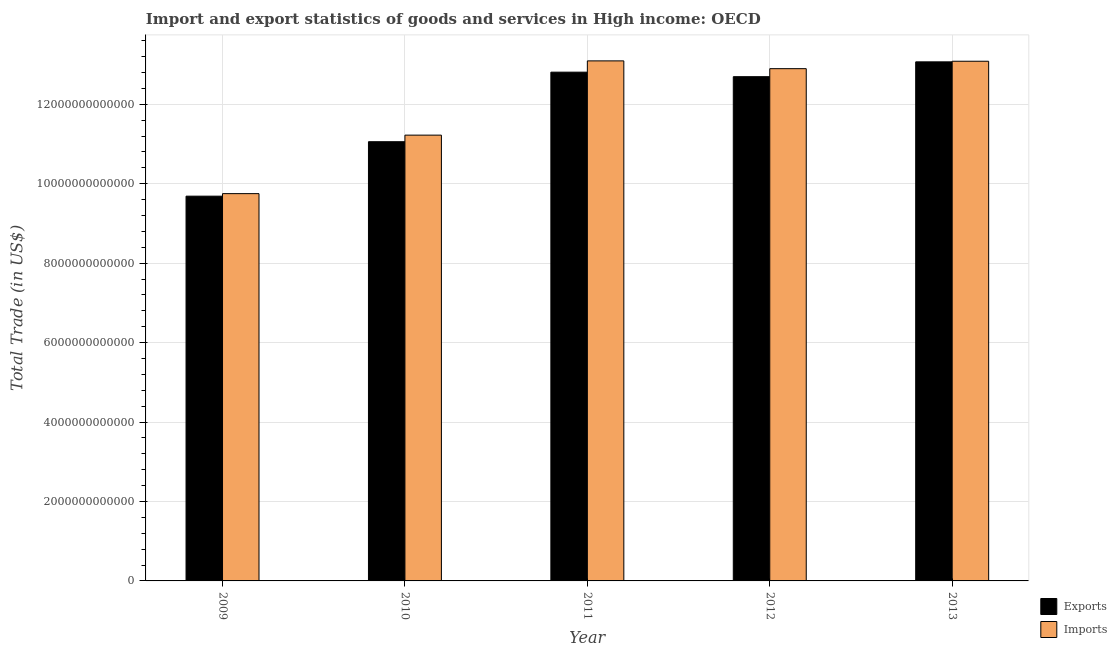How many different coloured bars are there?
Your answer should be very brief. 2. How many groups of bars are there?
Keep it short and to the point. 5. How many bars are there on the 1st tick from the left?
Your answer should be compact. 2. How many bars are there on the 5th tick from the right?
Provide a short and direct response. 2. What is the export of goods and services in 2009?
Give a very brief answer. 9.69e+12. Across all years, what is the maximum export of goods and services?
Offer a terse response. 1.31e+13. Across all years, what is the minimum export of goods and services?
Keep it short and to the point. 9.69e+12. In which year was the export of goods and services maximum?
Your response must be concise. 2013. What is the total export of goods and services in the graph?
Make the answer very short. 5.93e+13. What is the difference between the imports of goods and services in 2010 and that in 2011?
Ensure brevity in your answer.  -1.87e+12. What is the difference between the imports of goods and services in 2011 and the export of goods and services in 2012?
Provide a short and direct response. 1.96e+11. What is the average export of goods and services per year?
Offer a very short reply. 1.19e+13. In the year 2012, what is the difference between the imports of goods and services and export of goods and services?
Provide a succinct answer. 0. In how many years, is the imports of goods and services greater than 12000000000000 US$?
Your answer should be very brief. 3. What is the ratio of the export of goods and services in 2011 to that in 2013?
Your response must be concise. 0.98. Is the difference between the export of goods and services in 2009 and 2010 greater than the difference between the imports of goods and services in 2009 and 2010?
Offer a terse response. No. What is the difference between the highest and the second highest imports of goods and services?
Offer a terse response. 9.21e+09. What is the difference between the highest and the lowest imports of goods and services?
Make the answer very short. 3.34e+12. Is the sum of the export of goods and services in 2009 and 2012 greater than the maximum imports of goods and services across all years?
Your answer should be compact. Yes. What does the 1st bar from the left in 2013 represents?
Your answer should be very brief. Exports. What does the 2nd bar from the right in 2012 represents?
Offer a terse response. Exports. How many bars are there?
Make the answer very short. 10. Are all the bars in the graph horizontal?
Keep it short and to the point. No. How many years are there in the graph?
Keep it short and to the point. 5. What is the difference between two consecutive major ticks on the Y-axis?
Your answer should be compact. 2.00e+12. Does the graph contain any zero values?
Make the answer very short. No. Does the graph contain grids?
Your answer should be very brief. Yes. Where does the legend appear in the graph?
Make the answer very short. Bottom right. How many legend labels are there?
Provide a short and direct response. 2. What is the title of the graph?
Your answer should be compact. Import and export statistics of goods and services in High income: OECD. Does "Male population" appear as one of the legend labels in the graph?
Offer a very short reply. No. What is the label or title of the Y-axis?
Make the answer very short. Total Trade (in US$). What is the Total Trade (in US$) of Exports in 2009?
Keep it short and to the point. 9.69e+12. What is the Total Trade (in US$) in Imports in 2009?
Provide a short and direct response. 9.75e+12. What is the Total Trade (in US$) in Exports in 2010?
Offer a very short reply. 1.11e+13. What is the Total Trade (in US$) of Imports in 2010?
Ensure brevity in your answer.  1.12e+13. What is the Total Trade (in US$) in Exports in 2011?
Provide a succinct answer. 1.28e+13. What is the Total Trade (in US$) of Imports in 2011?
Provide a succinct answer. 1.31e+13. What is the Total Trade (in US$) in Exports in 2012?
Make the answer very short. 1.27e+13. What is the Total Trade (in US$) of Imports in 2012?
Provide a succinct answer. 1.29e+13. What is the Total Trade (in US$) of Exports in 2013?
Offer a very short reply. 1.31e+13. What is the Total Trade (in US$) of Imports in 2013?
Provide a succinct answer. 1.31e+13. Across all years, what is the maximum Total Trade (in US$) of Exports?
Offer a terse response. 1.31e+13. Across all years, what is the maximum Total Trade (in US$) in Imports?
Keep it short and to the point. 1.31e+13. Across all years, what is the minimum Total Trade (in US$) in Exports?
Provide a short and direct response. 9.69e+12. Across all years, what is the minimum Total Trade (in US$) in Imports?
Offer a terse response. 9.75e+12. What is the total Total Trade (in US$) in Exports in the graph?
Make the answer very short. 5.93e+13. What is the total Total Trade (in US$) of Imports in the graph?
Provide a short and direct response. 6.00e+13. What is the difference between the Total Trade (in US$) of Exports in 2009 and that in 2010?
Your response must be concise. -1.37e+12. What is the difference between the Total Trade (in US$) of Imports in 2009 and that in 2010?
Provide a short and direct response. -1.47e+12. What is the difference between the Total Trade (in US$) in Exports in 2009 and that in 2011?
Your answer should be very brief. -3.12e+12. What is the difference between the Total Trade (in US$) in Imports in 2009 and that in 2011?
Keep it short and to the point. -3.34e+12. What is the difference between the Total Trade (in US$) in Exports in 2009 and that in 2012?
Provide a short and direct response. -3.01e+12. What is the difference between the Total Trade (in US$) of Imports in 2009 and that in 2012?
Ensure brevity in your answer.  -3.15e+12. What is the difference between the Total Trade (in US$) in Exports in 2009 and that in 2013?
Keep it short and to the point. -3.38e+12. What is the difference between the Total Trade (in US$) of Imports in 2009 and that in 2013?
Your answer should be compact. -3.33e+12. What is the difference between the Total Trade (in US$) in Exports in 2010 and that in 2011?
Ensure brevity in your answer.  -1.75e+12. What is the difference between the Total Trade (in US$) of Imports in 2010 and that in 2011?
Give a very brief answer. -1.87e+12. What is the difference between the Total Trade (in US$) of Exports in 2010 and that in 2012?
Your answer should be very brief. -1.64e+12. What is the difference between the Total Trade (in US$) of Imports in 2010 and that in 2012?
Provide a succinct answer. -1.67e+12. What is the difference between the Total Trade (in US$) of Exports in 2010 and that in 2013?
Give a very brief answer. -2.01e+12. What is the difference between the Total Trade (in US$) of Imports in 2010 and that in 2013?
Provide a short and direct response. -1.86e+12. What is the difference between the Total Trade (in US$) in Exports in 2011 and that in 2012?
Offer a terse response. 1.14e+11. What is the difference between the Total Trade (in US$) in Imports in 2011 and that in 2012?
Keep it short and to the point. 1.96e+11. What is the difference between the Total Trade (in US$) in Exports in 2011 and that in 2013?
Provide a short and direct response. -2.60e+11. What is the difference between the Total Trade (in US$) in Imports in 2011 and that in 2013?
Provide a short and direct response. 9.21e+09. What is the difference between the Total Trade (in US$) of Exports in 2012 and that in 2013?
Your response must be concise. -3.73e+11. What is the difference between the Total Trade (in US$) of Imports in 2012 and that in 2013?
Your response must be concise. -1.87e+11. What is the difference between the Total Trade (in US$) of Exports in 2009 and the Total Trade (in US$) of Imports in 2010?
Ensure brevity in your answer.  -1.54e+12. What is the difference between the Total Trade (in US$) of Exports in 2009 and the Total Trade (in US$) of Imports in 2011?
Offer a very short reply. -3.41e+12. What is the difference between the Total Trade (in US$) in Exports in 2009 and the Total Trade (in US$) in Imports in 2012?
Ensure brevity in your answer.  -3.21e+12. What is the difference between the Total Trade (in US$) of Exports in 2009 and the Total Trade (in US$) of Imports in 2013?
Your response must be concise. -3.40e+12. What is the difference between the Total Trade (in US$) of Exports in 2010 and the Total Trade (in US$) of Imports in 2011?
Your answer should be compact. -2.04e+12. What is the difference between the Total Trade (in US$) in Exports in 2010 and the Total Trade (in US$) in Imports in 2012?
Provide a succinct answer. -1.84e+12. What is the difference between the Total Trade (in US$) of Exports in 2010 and the Total Trade (in US$) of Imports in 2013?
Provide a succinct answer. -2.03e+12. What is the difference between the Total Trade (in US$) in Exports in 2011 and the Total Trade (in US$) in Imports in 2012?
Offer a terse response. -8.81e+1. What is the difference between the Total Trade (in US$) in Exports in 2011 and the Total Trade (in US$) in Imports in 2013?
Keep it short and to the point. -2.75e+11. What is the difference between the Total Trade (in US$) of Exports in 2012 and the Total Trade (in US$) of Imports in 2013?
Keep it short and to the point. -3.89e+11. What is the average Total Trade (in US$) of Exports per year?
Your answer should be very brief. 1.19e+13. What is the average Total Trade (in US$) in Imports per year?
Make the answer very short. 1.20e+13. In the year 2009, what is the difference between the Total Trade (in US$) of Exports and Total Trade (in US$) of Imports?
Make the answer very short. -6.38e+1. In the year 2010, what is the difference between the Total Trade (in US$) of Exports and Total Trade (in US$) of Imports?
Keep it short and to the point. -1.66e+11. In the year 2011, what is the difference between the Total Trade (in US$) in Exports and Total Trade (in US$) in Imports?
Keep it short and to the point. -2.84e+11. In the year 2012, what is the difference between the Total Trade (in US$) in Exports and Total Trade (in US$) in Imports?
Offer a terse response. -2.02e+11. In the year 2013, what is the difference between the Total Trade (in US$) of Exports and Total Trade (in US$) of Imports?
Keep it short and to the point. -1.53e+1. What is the ratio of the Total Trade (in US$) of Exports in 2009 to that in 2010?
Provide a short and direct response. 0.88. What is the ratio of the Total Trade (in US$) of Imports in 2009 to that in 2010?
Keep it short and to the point. 0.87. What is the ratio of the Total Trade (in US$) in Exports in 2009 to that in 2011?
Provide a succinct answer. 0.76. What is the ratio of the Total Trade (in US$) of Imports in 2009 to that in 2011?
Keep it short and to the point. 0.74. What is the ratio of the Total Trade (in US$) in Exports in 2009 to that in 2012?
Ensure brevity in your answer.  0.76. What is the ratio of the Total Trade (in US$) of Imports in 2009 to that in 2012?
Keep it short and to the point. 0.76. What is the ratio of the Total Trade (in US$) in Exports in 2009 to that in 2013?
Offer a terse response. 0.74. What is the ratio of the Total Trade (in US$) of Imports in 2009 to that in 2013?
Offer a terse response. 0.75. What is the ratio of the Total Trade (in US$) of Exports in 2010 to that in 2011?
Give a very brief answer. 0.86. What is the ratio of the Total Trade (in US$) in Imports in 2010 to that in 2011?
Ensure brevity in your answer.  0.86. What is the ratio of the Total Trade (in US$) of Exports in 2010 to that in 2012?
Offer a very short reply. 0.87. What is the ratio of the Total Trade (in US$) in Imports in 2010 to that in 2012?
Provide a succinct answer. 0.87. What is the ratio of the Total Trade (in US$) of Exports in 2010 to that in 2013?
Give a very brief answer. 0.85. What is the ratio of the Total Trade (in US$) in Imports in 2010 to that in 2013?
Ensure brevity in your answer.  0.86. What is the ratio of the Total Trade (in US$) in Exports in 2011 to that in 2012?
Give a very brief answer. 1.01. What is the ratio of the Total Trade (in US$) in Imports in 2011 to that in 2012?
Your answer should be compact. 1.02. What is the ratio of the Total Trade (in US$) in Exports in 2011 to that in 2013?
Make the answer very short. 0.98. What is the ratio of the Total Trade (in US$) of Exports in 2012 to that in 2013?
Your response must be concise. 0.97. What is the ratio of the Total Trade (in US$) in Imports in 2012 to that in 2013?
Your response must be concise. 0.99. What is the difference between the highest and the second highest Total Trade (in US$) in Exports?
Provide a short and direct response. 2.60e+11. What is the difference between the highest and the second highest Total Trade (in US$) of Imports?
Keep it short and to the point. 9.21e+09. What is the difference between the highest and the lowest Total Trade (in US$) of Exports?
Give a very brief answer. 3.38e+12. What is the difference between the highest and the lowest Total Trade (in US$) of Imports?
Provide a succinct answer. 3.34e+12. 